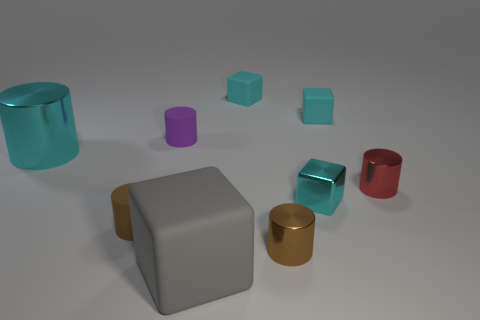How many cyan blocks must be subtracted to get 1 cyan blocks? 2 Subtract all yellow balls. How many cyan cubes are left? 3 Subtract all yellow cylinders. Subtract all purple cubes. How many cylinders are left? 5 Subtract all cylinders. How many objects are left? 4 Subtract 1 cyan cubes. How many objects are left? 8 Subtract all small brown objects. Subtract all tiny blue spheres. How many objects are left? 7 Add 8 tiny brown metal things. How many tiny brown metal things are left? 9 Add 2 gray metal blocks. How many gray metal blocks exist? 2 